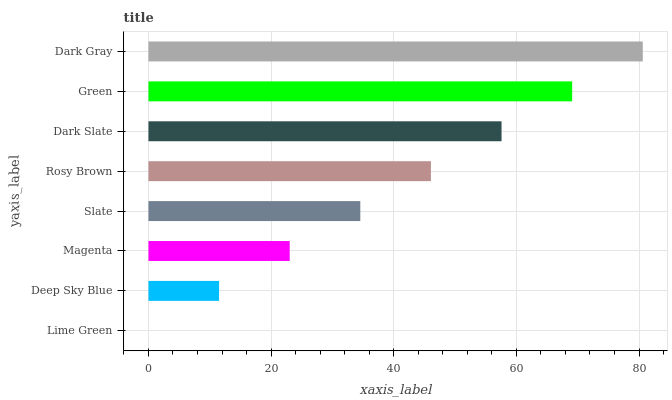Is Lime Green the minimum?
Answer yes or no. Yes. Is Dark Gray the maximum?
Answer yes or no. Yes. Is Deep Sky Blue the minimum?
Answer yes or no. No. Is Deep Sky Blue the maximum?
Answer yes or no. No. Is Deep Sky Blue greater than Lime Green?
Answer yes or no. Yes. Is Lime Green less than Deep Sky Blue?
Answer yes or no. Yes. Is Lime Green greater than Deep Sky Blue?
Answer yes or no. No. Is Deep Sky Blue less than Lime Green?
Answer yes or no. No. Is Rosy Brown the high median?
Answer yes or no. Yes. Is Slate the low median?
Answer yes or no. Yes. Is Green the high median?
Answer yes or no. No. Is Lime Green the low median?
Answer yes or no. No. 